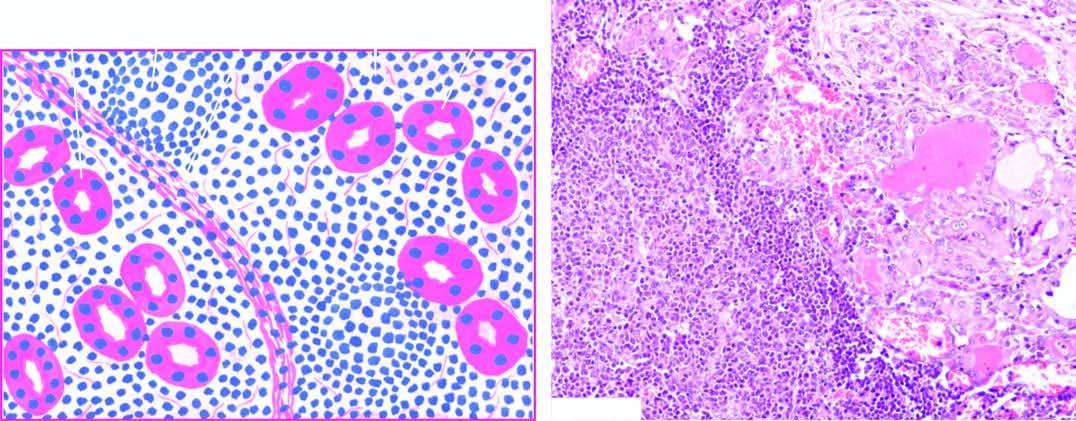do epithelial follicles include: lymphoid cell infiltration with formation of lymphoid follicles having germinal centres ; small, atrophic and colloid-deficient follicles ; presence of hurthle cells which have granular oxyphil cytoplasm and large irregula
Answer the question using a single word or phrase. No 